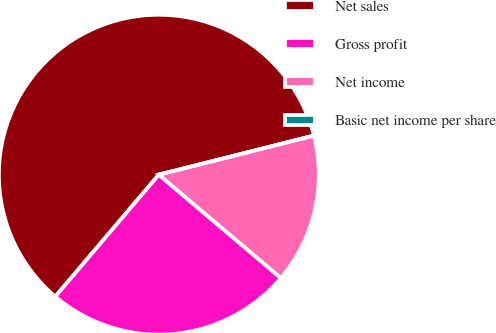<chart> <loc_0><loc_0><loc_500><loc_500><pie_chart><fcel>Net sales<fcel>Gross profit<fcel>Net income<fcel>Basic net income per share<nl><fcel>59.86%<fcel>25.03%<fcel>15.11%<fcel>0.0%<nl></chart> 